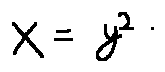Convert formula to latex. <formula><loc_0><loc_0><loc_500><loc_500>x = y ^ { 2 }</formula> 